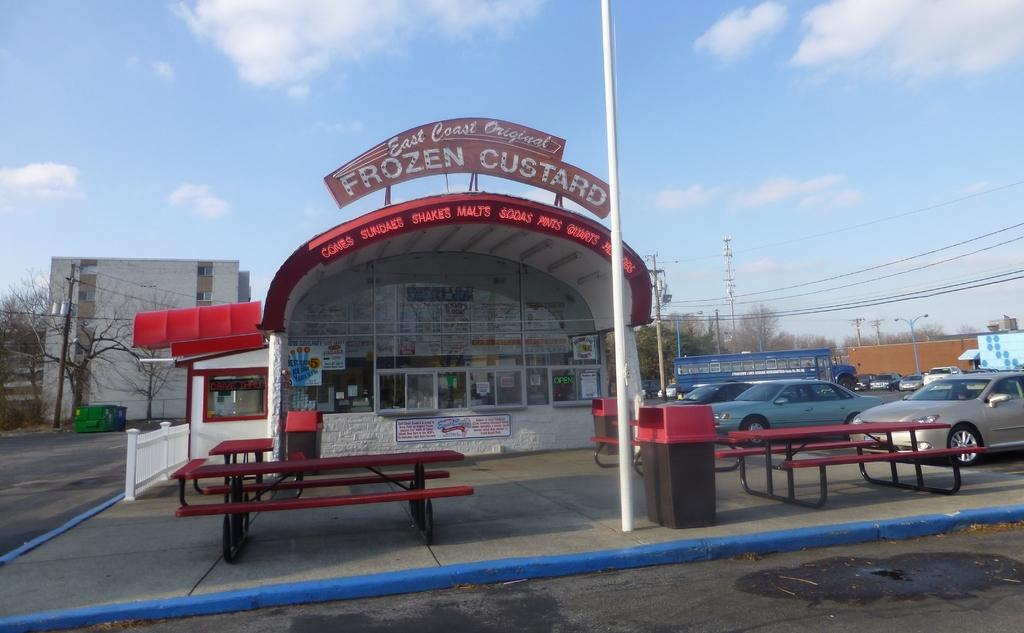What type of vehicles can be seen in the image? There are cars in the image. What structures are present in the image? There are poles, buildings, and a shed in the image. What type of seating is available in the image? There are benches in the image. What is the purpose of the board associated with the shed? The purpose of the board associated with the shed is not specified in the image. What can be found inside the shed? There are posters in the shed. Can you tell me how many people are involved in the argument taking place in the image? There is no argument present in the image. What type of sport is being played on the journey depicted in the image? There is no journey or volleyball game depicted in the image. 